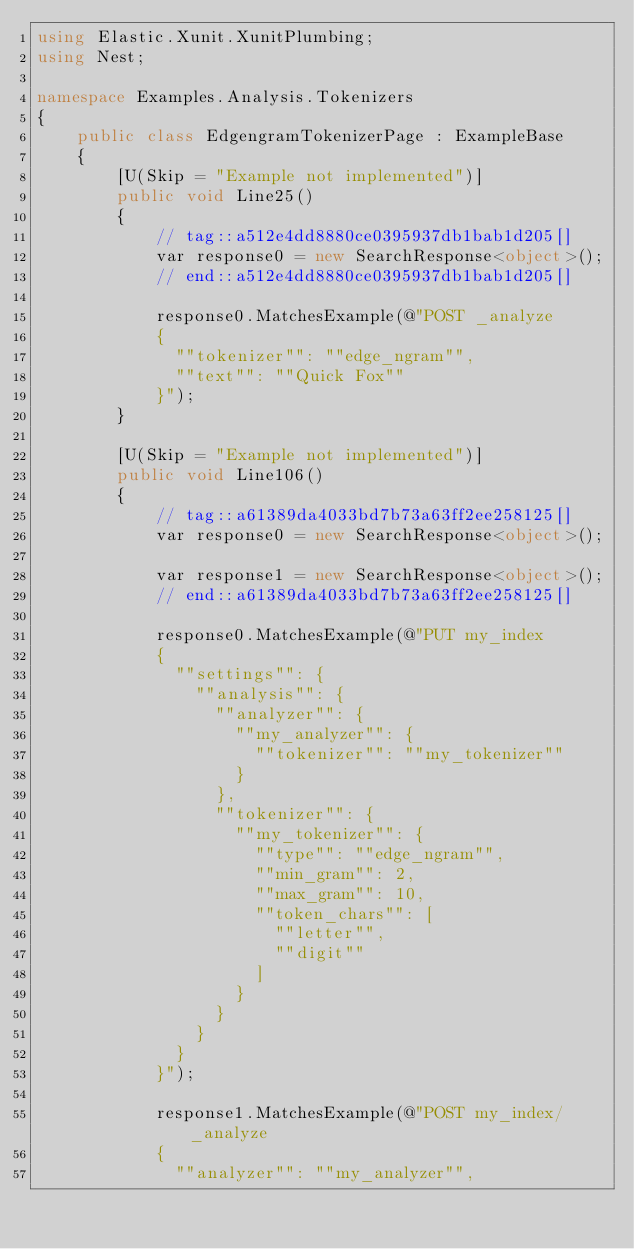Convert code to text. <code><loc_0><loc_0><loc_500><loc_500><_C#_>using Elastic.Xunit.XunitPlumbing;
using Nest;

namespace Examples.Analysis.Tokenizers
{
	public class EdgengramTokenizerPage : ExampleBase
	{
		[U(Skip = "Example not implemented")]
		public void Line25()
		{
			// tag::a512e4dd8880ce0395937db1bab1d205[]
			var response0 = new SearchResponse<object>();
			// end::a512e4dd8880ce0395937db1bab1d205[]

			response0.MatchesExample(@"POST _analyze
			{
			  ""tokenizer"": ""edge_ngram"",
			  ""text"": ""Quick Fox""
			}");
		}

		[U(Skip = "Example not implemented")]
		public void Line106()
		{
			// tag::a61389da4033bd7b73a63ff2ee258125[]
			var response0 = new SearchResponse<object>();

			var response1 = new SearchResponse<object>();
			// end::a61389da4033bd7b73a63ff2ee258125[]

			response0.MatchesExample(@"PUT my_index
			{
			  ""settings"": {
			    ""analysis"": {
			      ""analyzer"": {
			        ""my_analyzer"": {
			          ""tokenizer"": ""my_tokenizer""
			        }
			      },
			      ""tokenizer"": {
			        ""my_tokenizer"": {
			          ""type"": ""edge_ngram"",
			          ""min_gram"": 2,
			          ""max_gram"": 10,
			          ""token_chars"": [
			            ""letter"",
			            ""digit""
			          ]
			        }
			      }
			    }
			  }
			}");

			response1.MatchesExample(@"POST my_index/_analyze
			{
			  ""analyzer"": ""my_analyzer"",</code> 